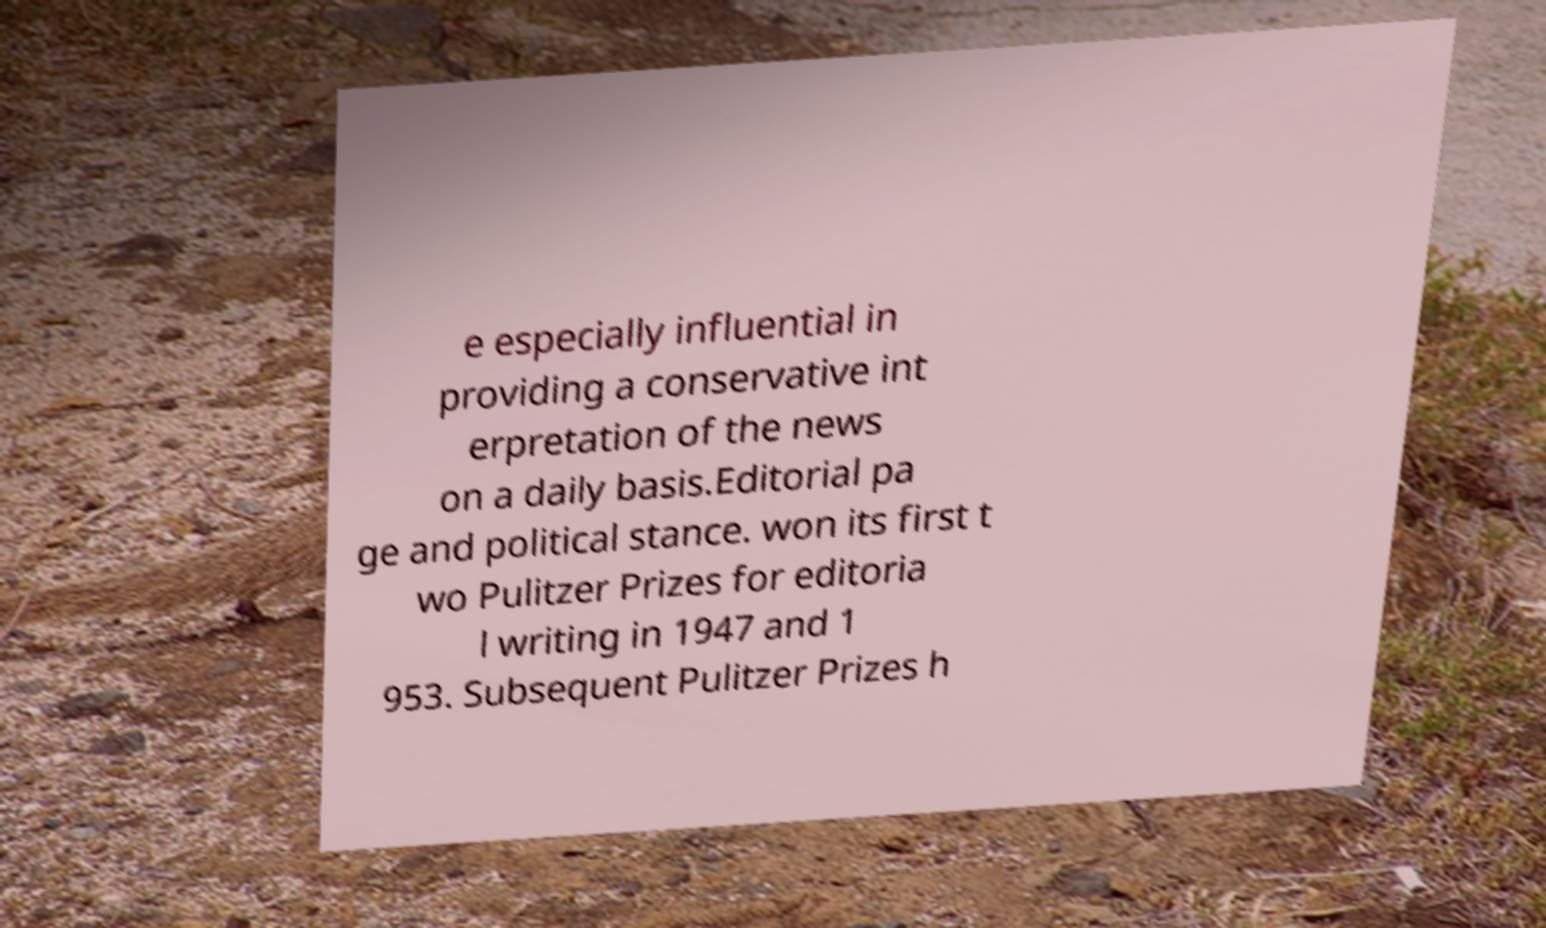Can you read and provide the text displayed in the image?This photo seems to have some interesting text. Can you extract and type it out for me? e especially influential in providing a conservative int erpretation of the news on a daily basis.Editorial pa ge and political stance. won its first t wo Pulitzer Prizes for editoria l writing in 1947 and 1 953. Subsequent Pulitzer Prizes h 